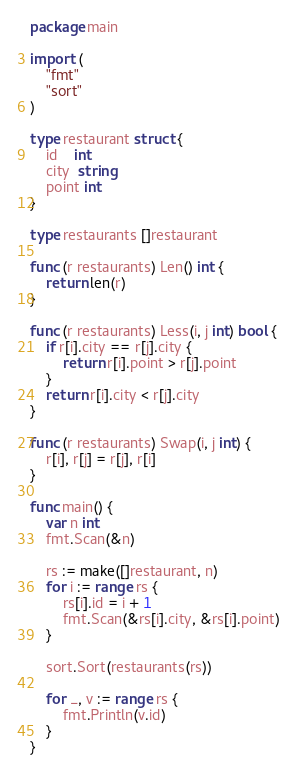Convert code to text. <code><loc_0><loc_0><loc_500><loc_500><_Go_>package main

import (
	"fmt"
	"sort"
)

type restaurant struct {
	id    int
	city  string
	point int
}

type restaurants []restaurant

func (r restaurants) Len() int {
	return len(r)
}

func (r restaurants) Less(i, j int) bool {
	if r[i].city == r[j].city {
		return r[i].point > r[j].point
	}
	return r[i].city < r[j].city
}

func (r restaurants) Swap(i, j int) {
	r[i], r[j] = r[j], r[i]
}

func main() {
	var n int
	fmt.Scan(&n)

	rs := make([]restaurant, n)
	for i := range rs {
		rs[i].id = i + 1
		fmt.Scan(&rs[i].city, &rs[i].point)
	}

	sort.Sort(restaurants(rs))

	for _, v := range rs {
		fmt.Println(v.id)
	}
}
</code> 